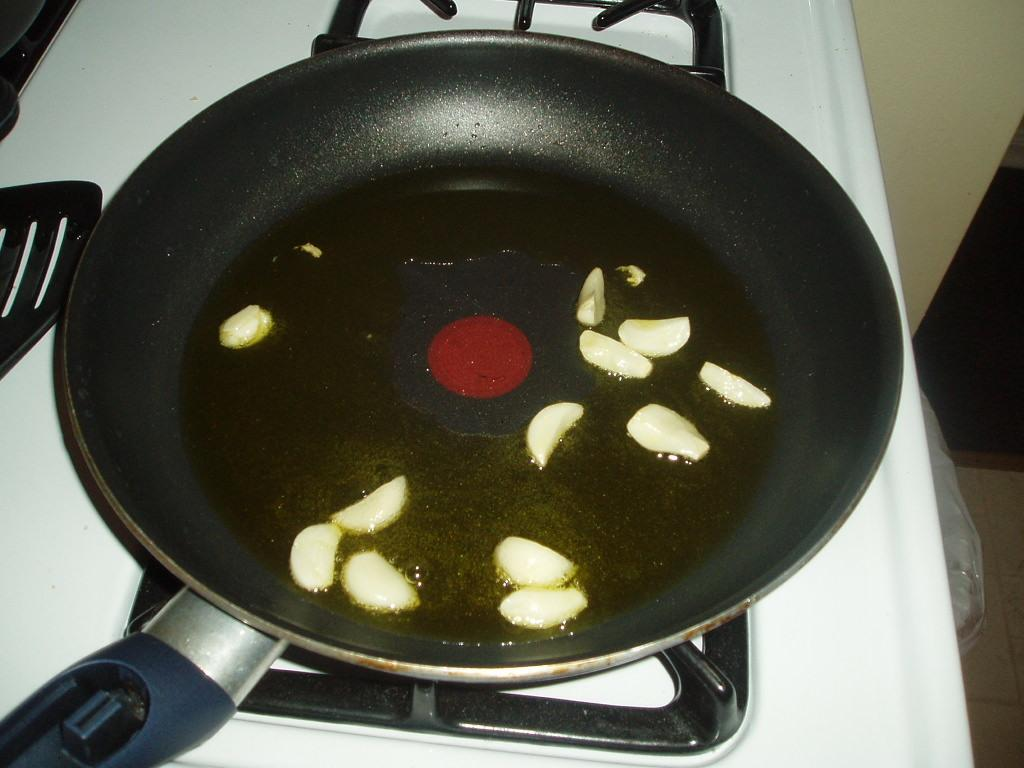What type of food item is present in the image? There are garlic pieces in the image. Where are the garlic pieces located? The garlic pieces are on a pan. What is the pan placed on? The pan is placed on a stove. How many sisters are sitting on the branch in the image? There are no sisters or branches present in the image; it features garlic pieces on a pan placed on a stove. 